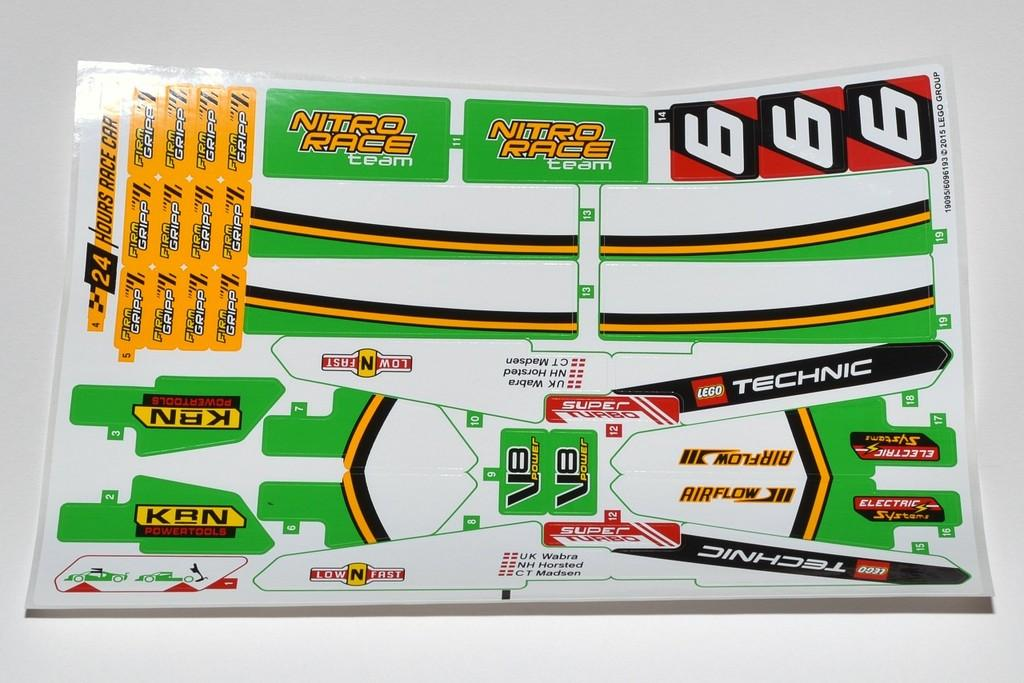<image>
Provide a brief description of the given image. a booklet item that had the letters KBN on it 